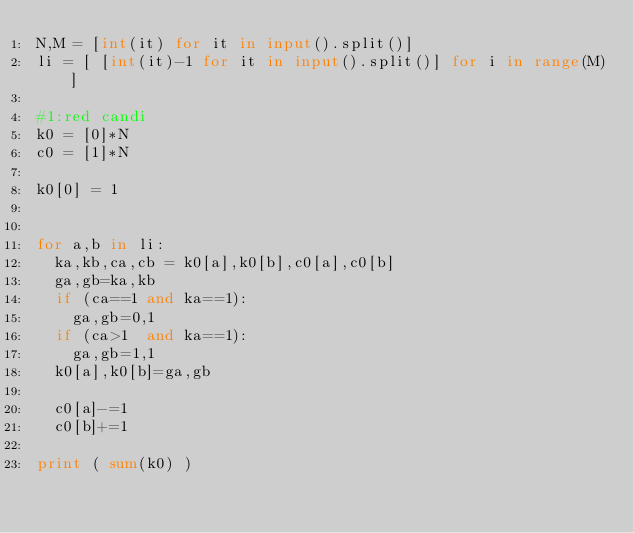<code> <loc_0><loc_0><loc_500><loc_500><_Python_>N,M = [int(it) for it in input().split()]
li = [ [int(it)-1 for it in input().split()] for i in range(M)]

#1:red candi
k0 = [0]*N
c0 = [1]*N

k0[0] = 1


for a,b in li:
  ka,kb,ca,cb = k0[a],k0[b],c0[a],c0[b]
  ga,gb=ka,kb
  if (ca==1 and ka==1):
    ga,gb=0,1
  if (ca>1  and ka==1):
    ga,gb=1,1
  k0[a],k0[b]=ga,gb

  c0[a]-=1
  c0[b]+=1
  
print ( sum(k0) )
  
    </code> 